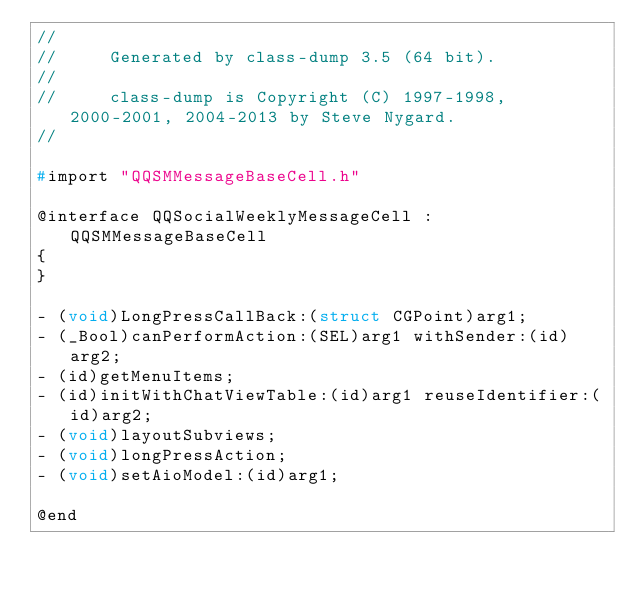<code> <loc_0><loc_0><loc_500><loc_500><_C_>//
//     Generated by class-dump 3.5 (64 bit).
//
//     class-dump is Copyright (C) 1997-1998, 2000-2001, 2004-2013 by Steve Nygard.
//

#import "QQSMMessageBaseCell.h"

@interface QQSocialWeeklyMessageCell : QQSMMessageBaseCell
{
}

- (void)LongPressCallBack:(struct CGPoint)arg1;
- (_Bool)canPerformAction:(SEL)arg1 withSender:(id)arg2;
- (id)getMenuItems;
- (id)initWithChatViewTable:(id)arg1 reuseIdentifier:(id)arg2;
- (void)layoutSubviews;
- (void)longPressAction;
- (void)setAioModel:(id)arg1;

@end

</code> 